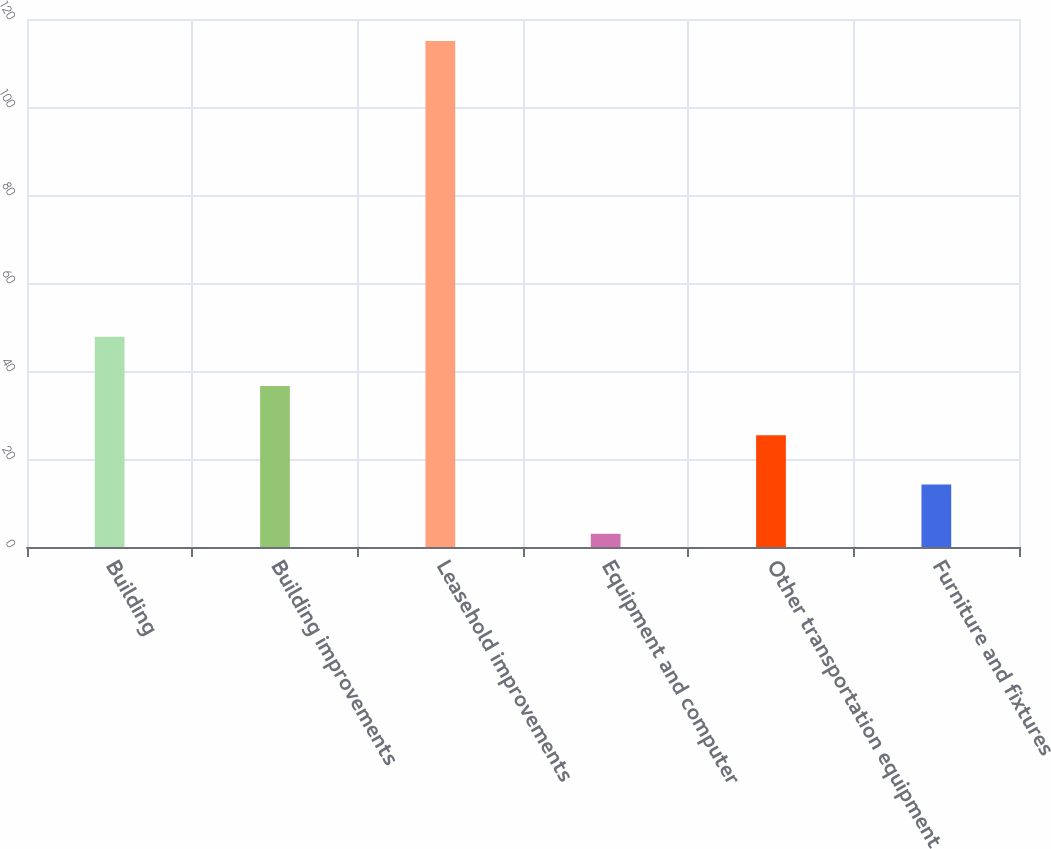<chart> <loc_0><loc_0><loc_500><loc_500><bar_chart><fcel>Building<fcel>Building improvements<fcel>Leasehold improvements<fcel>Equipment and computer<fcel>Other transportation equipment<fcel>Furniture and fixtures<nl><fcel>47.8<fcel>36.6<fcel>115<fcel>3<fcel>25.4<fcel>14.2<nl></chart> 